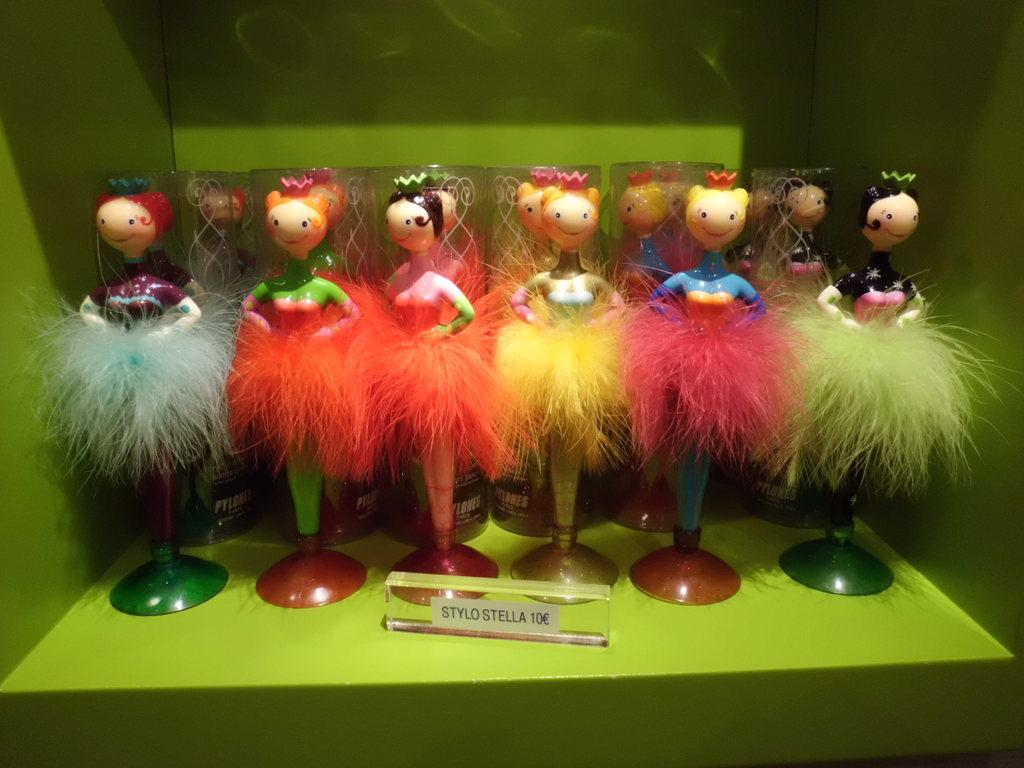What is the main subject of the image? The main subject of the image is a collection of dolls. What is the surface on which the dolls are placed? The dolls are placed on a green surface. Is there any other object or feature in front of the dolls? Yes, there is a glass bar with some name written on it in front of the dolls. What type of crook can be seen trying to get the attention of the dolls in the image? There is no crook or any indication of someone trying to get the attention of the dolls in the image. Where are the dolls placed on a shelf in the image? The dolls are not placed on a shelf; they are placed on a green surface. 